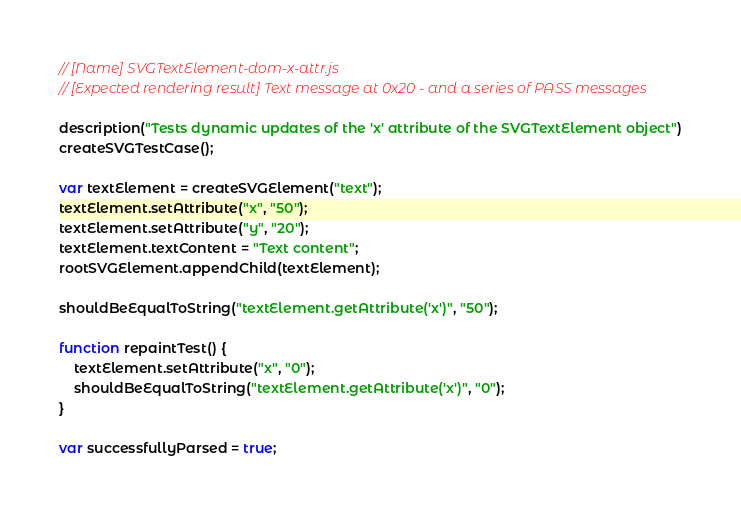Convert code to text. <code><loc_0><loc_0><loc_500><loc_500><_JavaScript_>// [Name] SVGTextElement-dom-x-attr.js
// [Expected rendering result] Text message at 0x20 - and a series of PASS messages

description("Tests dynamic updates of the 'x' attribute of the SVGTextElement object")
createSVGTestCase();

var textElement = createSVGElement("text");
textElement.setAttribute("x", "50");
textElement.setAttribute("y", "20");
textElement.textContent = "Text content";
rootSVGElement.appendChild(textElement);

shouldBeEqualToString("textElement.getAttribute('x')", "50");

function repaintTest() {
    textElement.setAttribute("x", "0");
    shouldBeEqualToString("textElement.getAttribute('x')", "0");
}

var successfullyParsed = true;
</code> 